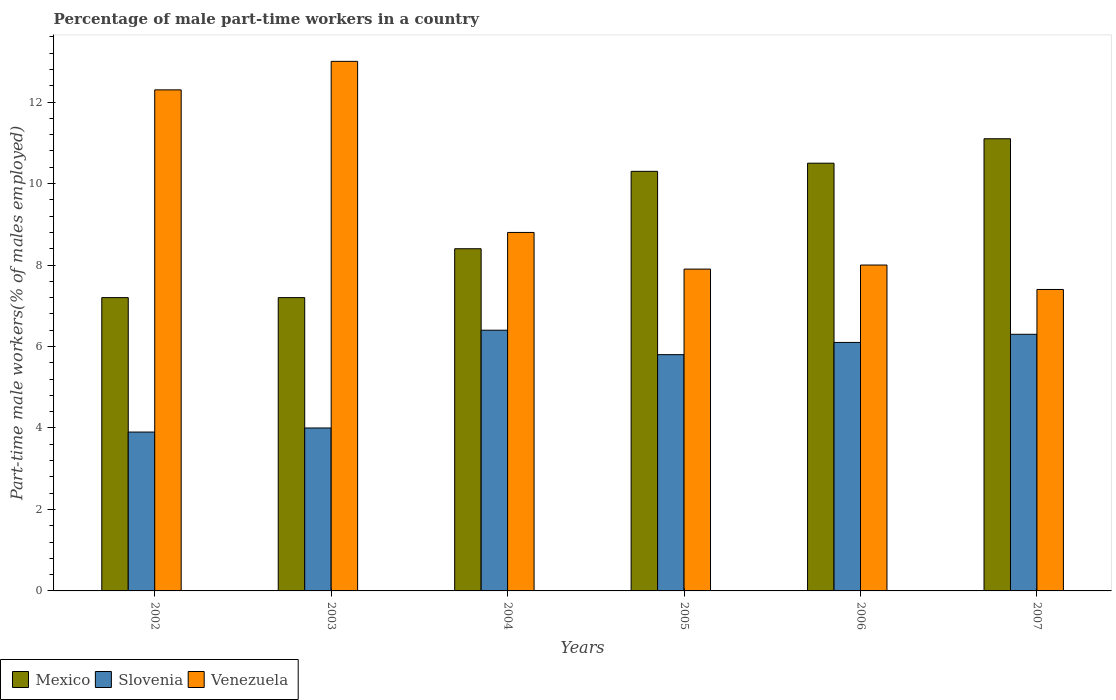How many groups of bars are there?
Your answer should be compact. 6. Are the number of bars on each tick of the X-axis equal?
Make the answer very short. Yes. How many bars are there on the 4th tick from the right?
Your answer should be compact. 3. What is the label of the 5th group of bars from the left?
Your answer should be compact. 2006. In how many cases, is the number of bars for a given year not equal to the number of legend labels?
Give a very brief answer. 0. What is the percentage of male part-time workers in Slovenia in 2007?
Ensure brevity in your answer.  6.3. Across all years, what is the maximum percentage of male part-time workers in Venezuela?
Your answer should be very brief. 13. Across all years, what is the minimum percentage of male part-time workers in Mexico?
Offer a very short reply. 7.2. In which year was the percentage of male part-time workers in Venezuela maximum?
Ensure brevity in your answer.  2003. What is the total percentage of male part-time workers in Venezuela in the graph?
Your response must be concise. 57.4. What is the difference between the percentage of male part-time workers in Venezuela in 2005 and that in 2007?
Your answer should be compact. 0.5. What is the difference between the percentage of male part-time workers in Venezuela in 2007 and the percentage of male part-time workers in Slovenia in 2006?
Your response must be concise. 1.3. What is the average percentage of male part-time workers in Mexico per year?
Provide a succinct answer. 9.12. In the year 2002, what is the difference between the percentage of male part-time workers in Mexico and percentage of male part-time workers in Venezuela?
Ensure brevity in your answer.  -5.1. In how many years, is the percentage of male part-time workers in Venezuela greater than 4 %?
Offer a terse response. 6. What is the ratio of the percentage of male part-time workers in Mexico in 2003 to that in 2006?
Make the answer very short. 0.69. Is the percentage of male part-time workers in Mexico in 2005 less than that in 2007?
Give a very brief answer. Yes. Is the difference between the percentage of male part-time workers in Mexico in 2004 and 2006 greater than the difference between the percentage of male part-time workers in Venezuela in 2004 and 2006?
Offer a very short reply. No. What is the difference between the highest and the second highest percentage of male part-time workers in Mexico?
Offer a terse response. 0.6. What is the difference between the highest and the lowest percentage of male part-time workers in Mexico?
Your response must be concise. 3.9. Is the sum of the percentage of male part-time workers in Slovenia in 2002 and 2003 greater than the maximum percentage of male part-time workers in Mexico across all years?
Make the answer very short. No. What does the 3rd bar from the left in 2002 represents?
Your answer should be very brief. Venezuela. What does the 2nd bar from the right in 2003 represents?
Your response must be concise. Slovenia. How many years are there in the graph?
Make the answer very short. 6. What is the difference between two consecutive major ticks on the Y-axis?
Give a very brief answer. 2. How many legend labels are there?
Make the answer very short. 3. How are the legend labels stacked?
Ensure brevity in your answer.  Horizontal. What is the title of the graph?
Offer a very short reply. Percentage of male part-time workers in a country. What is the label or title of the X-axis?
Offer a terse response. Years. What is the label or title of the Y-axis?
Your response must be concise. Part-time male workers(% of males employed). What is the Part-time male workers(% of males employed) in Mexico in 2002?
Provide a succinct answer. 7.2. What is the Part-time male workers(% of males employed) of Slovenia in 2002?
Ensure brevity in your answer.  3.9. What is the Part-time male workers(% of males employed) in Venezuela in 2002?
Offer a very short reply. 12.3. What is the Part-time male workers(% of males employed) in Mexico in 2003?
Offer a terse response. 7.2. What is the Part-time male workers(% of males employed) in Slovenia in 2003?
Provide a short and direct response. 4. What is the Part-time male workers(% of males employed) of Mexico in 2004?
Make the answer very short. 8.4. What is the Part-time male workers(% of males employed) of Slovenia in 2004?
Give a very brief answer. 6.4. What is the Part-time male workers(% of males employed) in Venezuela in 2004?
Your answer should be compact. 8.8. What is the Part-time male workers(% of males employed) of Mexico in 2005?
Offer a very short reply. 10.3. What is the Part-time male workers(% of males employed) of Slovenia in 2005?
Make the answer very short. 5.8. What is the Part-time male workers(% of males employed) of Venezuela in 2005?
Provide a short and direct response. 7.9. What is the Part-time male workers(% of males employed) in Slovenia in 2006?
Provide a succinct answer. 6.1. What is the Part-time male workers(% of males employed) in Venezuela in 2006?
Provide a succinct answer. 8. What is the Part-time male workers(% of males employed) in Mexico in 2007?
Offer a terse response. 11.1. What is the Part-time male workers(% of males employed) of Slovenia in 2007?
Your response must be concise. 6.3. What is the Part-time male workers(% of males employed) of Venezuela in 2007?
Offer a terse response. 7.4. Across all years, what is the maximum Part-time male workers(% of males employed) in Mexico?
Ensure brevity in your answer.  11.1. Across all years, what is the maximum Part-time male workers(% of males employed) of Slovenia?
Keep it short and to the point. 6.4. Across all years, what is the minimum Part-time male workers(% of males employed) of Mexico?
Keep it short and to the point. 7.2. Across all years, what is the minimum Part-time male workers(% of males employed) of Slovenia?
Give a very brief answer. 3.9. Across all years, what is the minimum Part-time male workers(% of males employed) of Venezuela?
Keep it short and to the point. 7.4. What is the total Part-time male workers(% of males employed) of Mexico in the graph?
Your answer should be compact. 54.7. What is the total Part-time male workers(% of males employed) in Slovenia in the graph?
Give a very brief answer. 32.5. What is the total Part-time male workers(% of males employed) in Venezuela in the graph?
Provide a short and direct response. 57.4. What is the difference between the Part-time male workers(% of males employed) in Slovenia in 2002 and that in 2003?
Provide a succinct answer. -0.1. What is the difference between the Part-time male workers(% of males employed) of Venezuela in 2002 and that in 2003?
Make the answer very short. -0.7. What is the difference between the Part-time male workers(% of males employed) in Slovenia in 2002 and that in 2004?
Your answer should be very brief. -2.5. What is the difference between the Part-time male workers(% of males employed) in Venezuela in 2002 and that in 2004?
Give a very brief answer. 3.5. What is the difference between the Part-time male workers(% of males employed) in Mexico in 2002 and that in 2005?
Provide a succinct answer. -3.1. What is the difference between the Part-time male workers(% of males employed) of Slovenia in 2002 and that in 2005?
Provide a succinct answer. -1.9. What is the difference between the Part-time male workers(% of males employed) of Venezuela in 2002 and that in 2005?
Your response must be concise. 4.4. What is the difference between the Part-time male workers(% of males employed) in Mexico in 2002 and that in 2006?
Make the answer very short. -3.3. What is the difference between the Part-time male workers(% of males employed) of Slovenia in 2002 and that in 2006?
Your answer should be very brief. -2.2. What is the difference between the Part-time male workers(% of males employed) in Venezuela in 2002 and that in 2007?
Offer a very short reply. 4.9. What is the difference between the Part-time male workers(% of males employed) of Mexico in 2003 and that in 2004?
Offer a terse response. -1.2. What is the difference between the Part-time male workers(% of males employed) of Venezuela in 2003 and that in 2005?
Make the answer very short. 5.1. What is the difference between the Part-time male workers(% of males employed) of Venezuela in 2003 and that in 2006?
Your answer should be compact. 5. What is the difference between the Part-time male workers(% of males employed) of Mexico in 2003 and that in 2007?
Offer a terse response. -3.9. What is the difference between the Part-time male workers(% of males employed) of Venezuela in 2003 and that in 2007?
Your response must be concise. 5.6. What is the difference between the Part-time male workers(% of males employed) in Venezuela in 2004 and that in 2005?
Ensure brevity in your answer.  0.9. What is the difference between the Part-time male workers(% of males employed) in Mexico in 2004 and that in 2006?
Keep it short and to the point. -2.1. What is the difference between the Part-time male workers(% of males employed) of Venezuela in 2004 and that in 2006?
Your answer should be very brief. 0.8. What is the difference between the Part-time male workers(% of males employed) in Mexico in 2004 and that in 2007?
Give a very brief answer. -2.7. What is the difference between the Part-time male workers(% of males employed) of Slovenia in 2004 and that in 2007?
Offer a very short reply. 0.1. What is the difference between the Part-time male workers(% of males employed) of Slovenia in 2005 and that in 2007?
Give a very brief answer. -0.5. What is the difference between the Part-time male workers(% of males employed) in Mexico in 2006 and that in 2007?
Offer a very short reply. -0.6. What is the difference between the Part-time male workers(% of males employed) in Slovenia in 2006 and that in 2007?
Give a very brief answer. -0.2. What is the difference between the Part-time male workers(% of males employed) of Venezuela in 2006 and that in 2007?
Provide a short and direct response. 0.6. What is the difference between the Part-time male workers(% of males employed) of Mexico in 2002 and the Part-time male workers(% of males employed) of Slovenia in 2003?
Give a very brief answer. 3.2. What is the difference between the Part-time male workers(% of males employed) of Slovenia in 2002 and the Part-time male workers(% of males employed) of Venezuela in 2003?
Provide a short and direct response. -9.1. What is the difference between the Part-time male workers(% of males employed) of Mexico in 2002 and the Part-time male workers(% of males employed) of Slovenia in 2004?
Offer a very short reply. 0.8. What is the difference between the Part-time male workers(% of males employed) in Slovenia in 2002 and the Part-time male workers(% of males employed) in Venezuela in 2004?
Provide a short and direct response. -4.9. What is the difference between the Part-time male workers(% of males employed) in Mexico in 2002 and the Part-time male workers(% of males employed) in Venezuela in 2005?
Provide a succinct answer. -0.7. What is the difference between the Part-time male workers(% of males employed) of Slovenia in 2002 and the Part-time male workers(% of males employed) of Venezuela in 2005?
Offer a terse response. -4. What is the difference between the Part-time male workers(% of males employed) in Mexico in 2002 and the Part-time male workers(% of males employed) in Slovenia in 2006?
Your answer should be compact. 1.1. What is the difference between the Part-time male workers(% of males employed) in Mexico in 2002 and the Part-time male workers(% of males employed) in Venezuela in 2006?
Keep it short and to the point. -0.8. What is the difference between the Part-time male workers(% of males employed) in Mexico in 2002 and the Part-time male workers(% of males employed) in Slovenia in 2007?
Provide a succinct answer. 0.9. What is the difference between the Part-time male workers(% of males employed) of Mexico in 2003 and the Part-time male workers(% of males employed) of Slovenia in 2004?
Provide a short and direct response. 0.8. What is the difference between the Part-time male workers(% of males employed) in Mexico in 2003 and the Part-time male workers(% of males employed) in Venezuela in 2004?
Your answer should be compact. -1.6. What is the difference between the Part-time male workers(% of males employed) in Slovenia in 2003 and the Part-time male workers(% of males employed) in Venezuela in 2004?
Provide a short and direct response. -4.8. What is the difference between the Part-time male workers(% of males employed) in Mexico in 2003 and the Part-time male workers(% of males employed) in Slovenia in 2005?
Offer a terse response. 1.4. What is the difference between the Part-time male workers(% of males employed) of Mexico in 2003 and the Part-time male workers(% of males employed) of Slovenia in 2007?
Your response must be concise. 0.9. What is the difference between the Part-time male workers(% of males employed) of Slovenia in 2003 and the Part-time male workers(% of males employed) of Venezuela in 2007?
Make the answer very short. -3.4. What is the difference between the Part-time male workers(% of males employed) of Slovenia in 2004 and the Part-time male workers(% of males employed) of Venezuela in 2005?
Your response must be concise. -1.5. What is the difference between the Part-time male workers(% of males employed) in Mexico in 2004 and the Part-time male workers(% of males employed) in Slovenia in 2006?
Offer a very short reply. 2.3. What is the difference between the Part-time male workers(% of males employed) in Mexico in 2004 and the Part-time male workers(% of males employed) in Slovenia in 2007?
Offer a terse response. 2.1. What is the difference between the Part-time male workers(% of males employed) of Mexico in 2004 and the Part-time male workers(% of males employed) of Venezuela in 2007?
Provide a short and direct response. 1. What is the difference between the Part-time male workers(% of males employed) in Slovenia in 2004 and the Part-time male workers(% of males employed) in Venezuela in 2007?
Ensure brevity in your answer.  -1. What is the difference between the Part-time male workers(% of males employed) in Mexico in 2005 and the Part-time male workers(% of males employed) in Slovenia in 2006?
Offer a terse response. 4.2. What is the difference between the Part-time male workers(% of males employed) of Slovenia in 2005 and the Part-time male workers(% of males employed) of Venezuela in 2006?
Provide a succinct answer. -2.2. What is the difference between the Part-time male workers(% of males employed) of Slovenia in 2005 and the Part-time male workers(% of males employed) of Venezuela in 2007?
Provide a succinct answer. -1.6. What is the difference between the Part-time male workers(% of males employed) of Mexico in 2006 and the Part-time male workers(% of males employed) of Slovenia in 2007?
Offer a terse response. 4.2. What is the average Part-time male workers(% of males employed) of Mexico per year?
Keep it short and to the point. 9.12. What is the average Part-time male workers(% of males employed) in Slovenia per year?
Your response must be concise. 5.42. What is the average Part-time male workers(% of males employed) in Venezuela per year?
Your answer should be compact. 9.57. In the year 2002, what is the difference between the Part-time male workers(% of males employed) in Mexico and Part-time male workers(% of males employed) in Slovenia?
Your response must be concise. 3.3. In the year 2002, what is the difference between the Part-time male workers(% of males employed) in Mexico and Part-time male workers(% of males employed) in Venezuela?
Keep it short and to the point. -5.1. In the year 2002, what is the difference between the Part-time male workers(% of males employed) of Slovenia and Part-time male workers(% of males employed) of Venezuela?
Ensure brevity in your answer.  -8.4. In the year 2005, what is the difference between the Part-time male workers(% of males employed) in Mexico and Part-time male workers(% of males employed) in Slovenia?
Give a very brief answer. 4.5. In the year 2005, what is the difference between the Part-time male workers(% of males employed) in Slovenia and Part-time male workers(% of males employed) in Venezuela?
Provide a short and direct response. -2.1. In the year 2006, what is the difference between the Part-time male workers(% of males employed) in Mexico and Part-time male workers(% of males employed) in Venezuela?
Your response must be concise. 2.5. In the year 2006, what is the difference between the Part-time male workers(% of males employed) in Slovenia and Part-time male workers(% of males employed) in Venezuela?
Give a very brief answer. -1.9. What is the ratio of the Part-time male workers(% of males employed) of Slovenia in 2002 to that in 2003?
Provide a short and direct response. 0.97. What is the ratio of the Part-time male workers(% of males employed) in Venezuela in 2002 to that in 2003?
Offer a very short reply. 0.95. What is the ratio of the Part-time male workers(% of males employed) in Slovenia in 2002 to that in 2004?
Provide a succinct answer. 0.61. What is the ratio of the Part-time male workers(% of males employed) in Venezuela in 2002 to that in 2004?
Offer a terse response. 1.4. What is the ratio of the Part-time male workers(% of males employed) of Mexico in 2002 to that in 2005?
Keep it short and to the point. 0.7. What is the ratio of the Part-time male workers(% of males employed) of Slovenia in 2002 to that in 2005?
Give a very brief answer. 0.67. What is the ratio of the Part-time male workers(% of males employed) of Venezuela in 2002 to that in 2005?
Offer a terse response. 1.56. What is the ratio of the Part-time male workers(% of males employed) in Mexico in 2002 to that in 2006?
Provide a succinct answer. 0.69. What is the ratio of the Part-time male workers(% of males employed) in Slovenia in 2002 to that in 2006?
Offer a terse response. 0.64. What is the ratio of the Part-time male workers(% of males employed) of Venezuela in 2002 to that in 2006?
Your response must be concise. 1.54. What is the ratio of the Part-time male workers(% of males employed) of Mexico in 2002 to that in 2007?
Ensure brevity in your answer.  0.65. What is the ratio of the Part-time male workers(% of males employed) of Slovenia in 2002 to that in 2007?
Provide a short and direct response. 0.62. What is the ratio of the Part-time male workers(% of males employed) in Venezuela in 2002 to that in 2007?
Give a very brief answer. 1.66. What is the ratio of the Part-time male workers(% of males employed) of Venezuela in 2003 to that in 2004?
Your answer should be compact. 1.48. What is the ratio of the Part-time male workers(% of males employed) of Mexico in 2003 to that in 2005?
Your answer should be very brief. 0.7. What is the ratio of the Part-time male workers(% of males employed) of Slovenia in 2003 to that in 2005?
Offer a terse response. 0.69. What is the ratio of the Part-time male workers(% of males employed) of Venezuela in 2003 to that in 2005?
Ensure brevity in your answer.  1.65. What is the ratio of the Part-time male workers(% of males employed) of Mexico in 2003 to that in 2006?
Offer a terse response. 0.69. What is the ratio of the Part-time male workers(% of males employed) of Slovenia in 2003 to that in 2006?
Provide a succinct answer. 0.66. What is the ratio of the Part-time male workers(% of males employed) in Venezuela in 2003 to that in 2006?
Make the answer very short. 1.62. What is the ratio of the Part-time male workers(% of males employed) of Mexico in 2003 to that in 2007?
Your answer should be compact. 0.65. What is the ratio of the Part-time male workers(% of males employed) of Slovenia in 2003 to that in 2007?
Give a very brief answer. 0.63. What is the ratio of the Part-time male workers(% of males employed) of Venezuela in 2003 to that in 2007?
Provide a succinct answer. 1.76. What is the ratio of the Part-time male workers(% of males employed) in Mexico in 2004 to that in 2005?
Make the answer very short. 0.82. What is the ratio of the Part-time male workers(% of males employed) of Slovenia in 2004 to that in 2005?
Give a very brief answer. 1.1. What is the ratio of the Part-time male workers(% of males employed) of Venezuela in 2004 to that in 2005?
Make the answer very short. 1.11. What is the ratio of the Part-time male workers(% of males employed) in Mexico in 2004 to that in 2006?
Your answer should be very brief. 0.8. What is the ratio of the Part-time male workers(% of males employed) in Slovenia in 2004 to that in 2006?
Give a very brief answer. 1.05. What is the ratio of the Part-time male workers(% of males employed) of Mexico in 2004 to that in 2007?
Your answer should be compact. 0.76. What is the ratio of the Part-time male workers(% of males employed) of Slovenia in 2004 to that in 2007?
Keep it short and to the point. 1.02. What is the ratio of the Part-time male workers(% of males employed) of Venezuela in 2004 to that in 2007?
Offer a terse response. 1.19. What is the ratio of the Part-time male workers(% of males employed) in Mexico in 2005 to that in 2006?
Your response must be concise. 0.98. What is the ratio of the Part-time male workers(% of males employed) of Slovenia in 2005 to that in 2006?
Keep it short and to the point. 0.95. What is the ratio of the Part-time male workers(% of males employed) of Venezuela in 2005 to that in 2006?
Keep it short and to the point. 0.99. What is the ratio of the Part-time male workers(% of males employed) of Mexico in 2005 to that in 2007?
Make the answer very short. 0.93. What is the ratio of the Part-time male workers(% of males employed) of Slovenia in 2005 to that in 2007?
Give a very brief answer. 0.92. What is the ratio of the Part-time male workers(% of males employed) of Venezuela in 2005 to that in 2007?
Offer a very short reply. 1.07. What is the ratio of the Part-time male workers(% of males employed) of Mexico in 2006 to that in 2007?
Provide a short and direct response. 0.95. What is the ratio of the Part-time male workers(% of males employed) in Slovenia in 2006 to that in 2007?
Your response must be concise. 0.97. What is the ratio of the Part-time male workers(% of males employed) of Venezuela in 2006 to that in 2007?
Keep it short and to the point. 1.08. What is the difference between the highest and the second highest Part-time male workers(% of males employed) of Venezuela?
Offer a very short reply. 0.7. What is the difference between the highest and the lowest Part-time male workers(% of males employed) of Slovenia?
Keep it short and to the point. 2.5. 